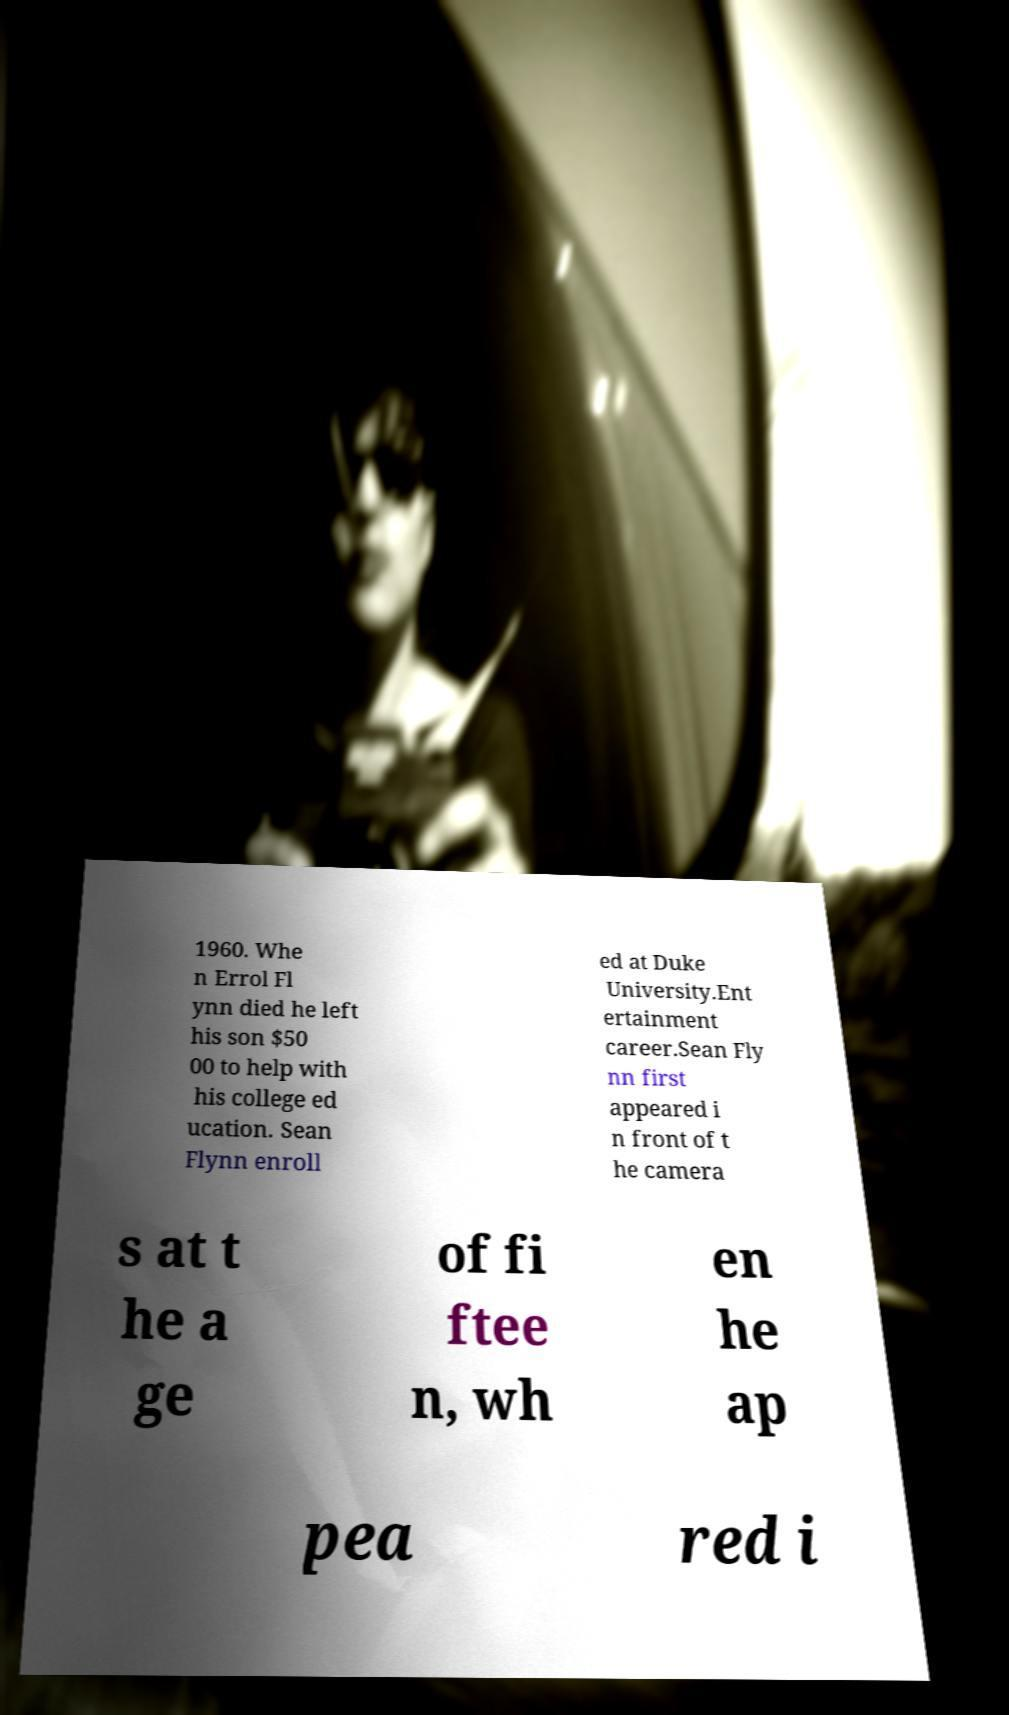Could you assist in decoding the text presented in this image and type it out clearly? 1960. Whe n Errol Fl ynn died he left his son $50 00 to help with his college ed ucation. Sean Flynn enroll ed at Duke University.Ent ertainment career.Sean Fly nn first appeared i n front of t he camera s at t he a ge of fi ftee n, wh en he ap pea red i 